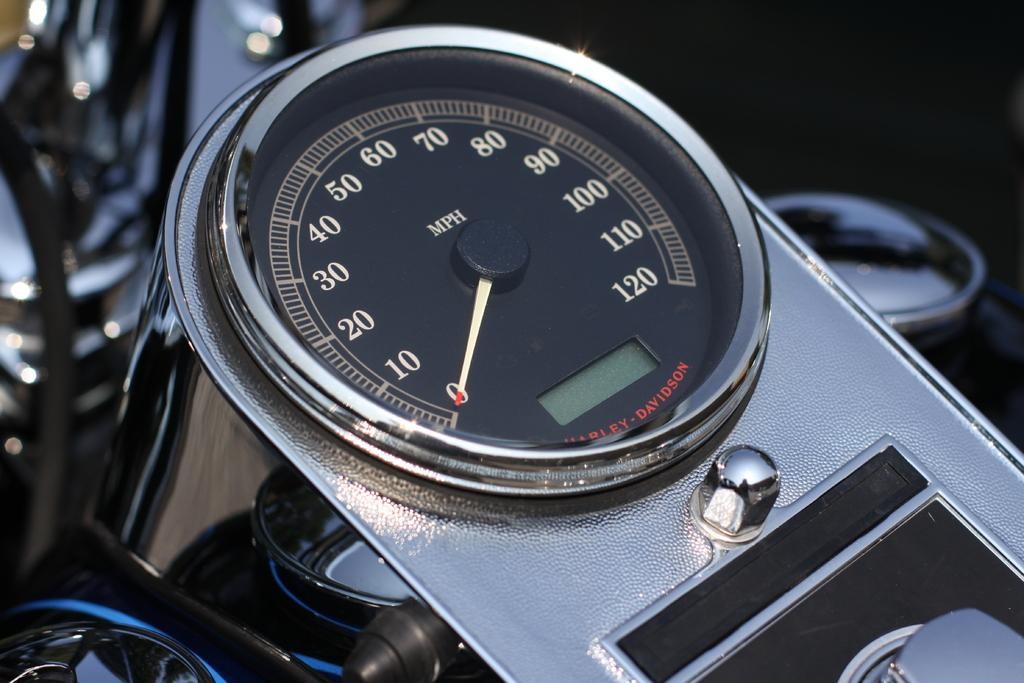What type of instrument is visible in the image? There is a speedometer in the image. What vehicle does the speedometer belong to? The speedometer is on a motorcycle. How many beds can be seen in the image? There are no beds present in the image. What type of connection is established between the speedometer and the motorcycle? The speedometer is directly attached to the motorcycle, so there is a physical connection between the two. 